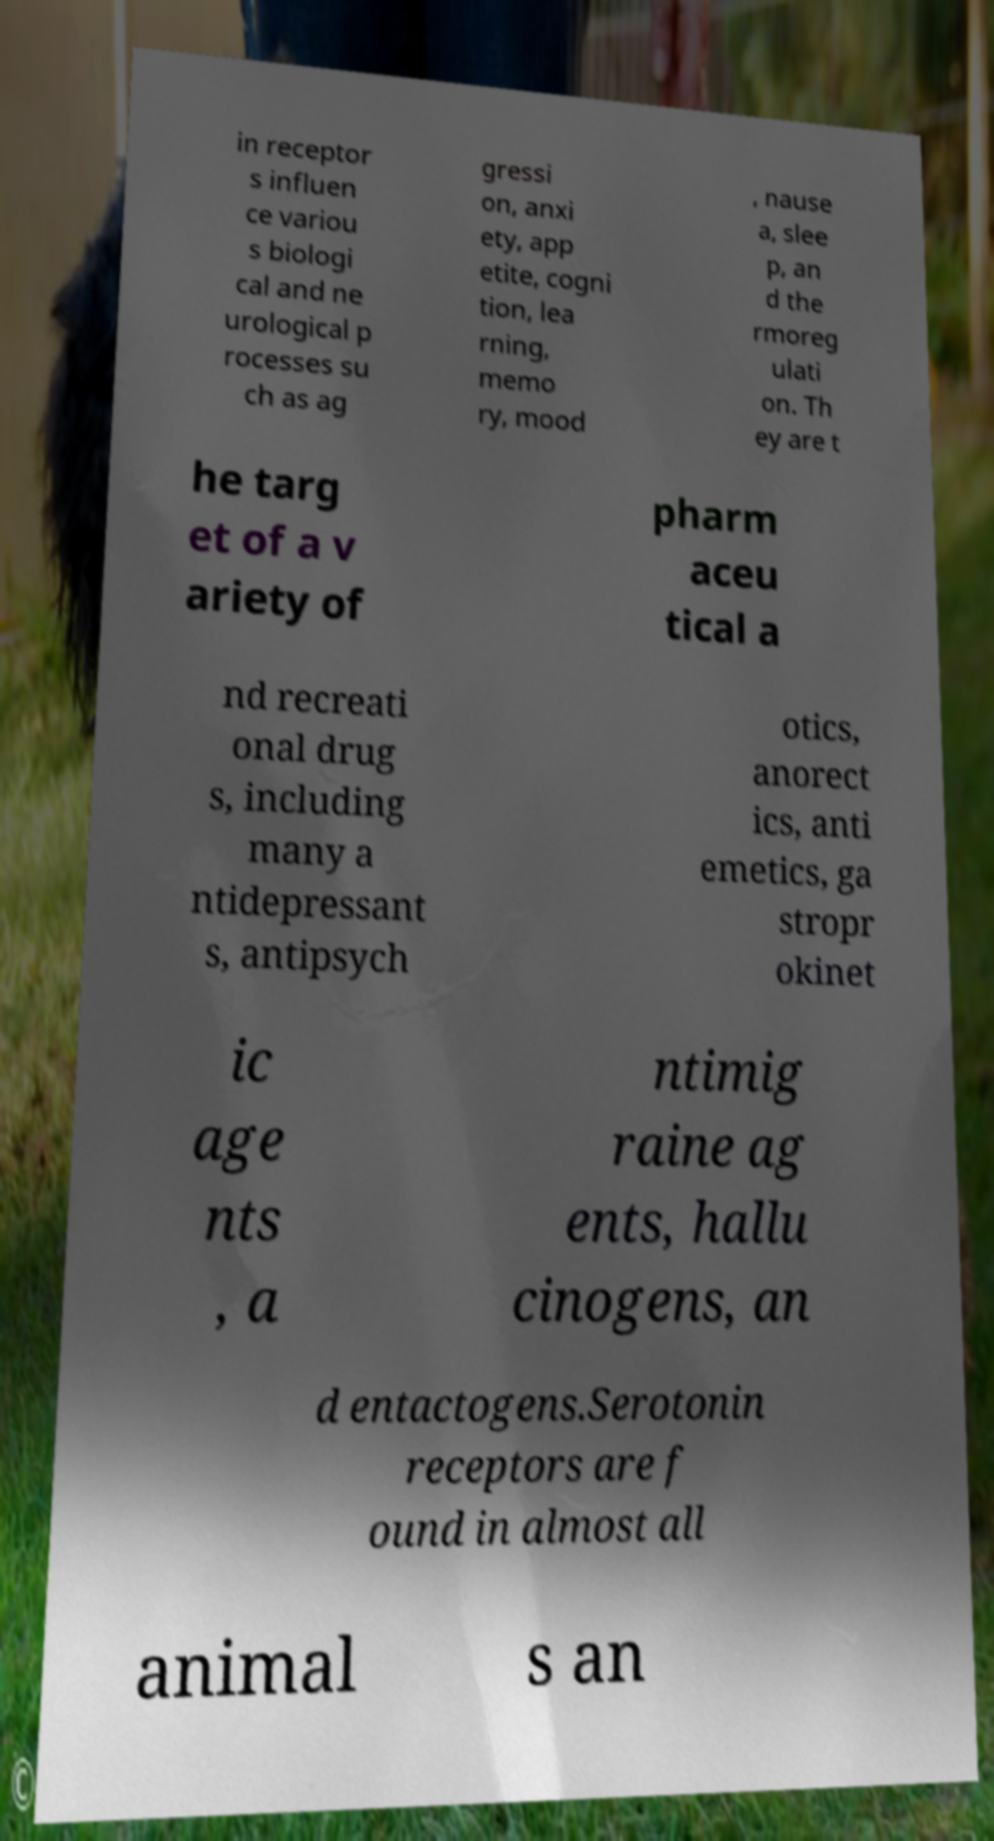For documentation purposes, I need the text within this image transcribed. Could you provide that? in receptor s influen ce variou s biologi cal and ne urological p rocesses su ch as ag gressi on, anxi ety, app etite, cogni tion, lea rning, memo ry, mood , nause a, slee p, an d the rmoreg ulati on. Th ey are t he targ et of a v ariety of pharm aceu tical a nd recreati onal drug s, including many a ntidepressant s, antipsych otics, anorect ics, anti emetics, ga stropr okinet ic age nts , a ntimig raine ag ents, hallu cinogens, an d entactogens.Serotonin receptors are f ound in almost all animal s an 